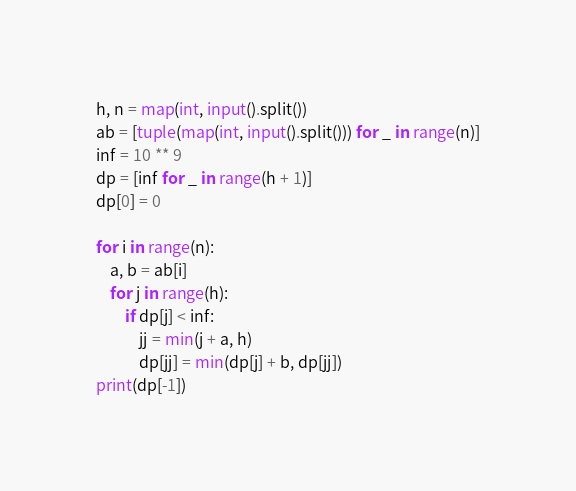<code> <loc_0><loc_0><loc_500><loc_500><_Python_>h, n = map(int, input().split())
ab = [tuple(map(int, input().split())) for _ in range(n)]
inf = 10 ** 9
dp = [inf for _ in range(h + 1)]
dp[0] = 0

for i in range(n):
    a, b = ab[i]
    for j in range(h):
        if dp[j] < inf:
            jj = min(j + a, h)
            dp[jj] = min(dp[j] + b, dp[jj])
print(dp[-1])
</code> 